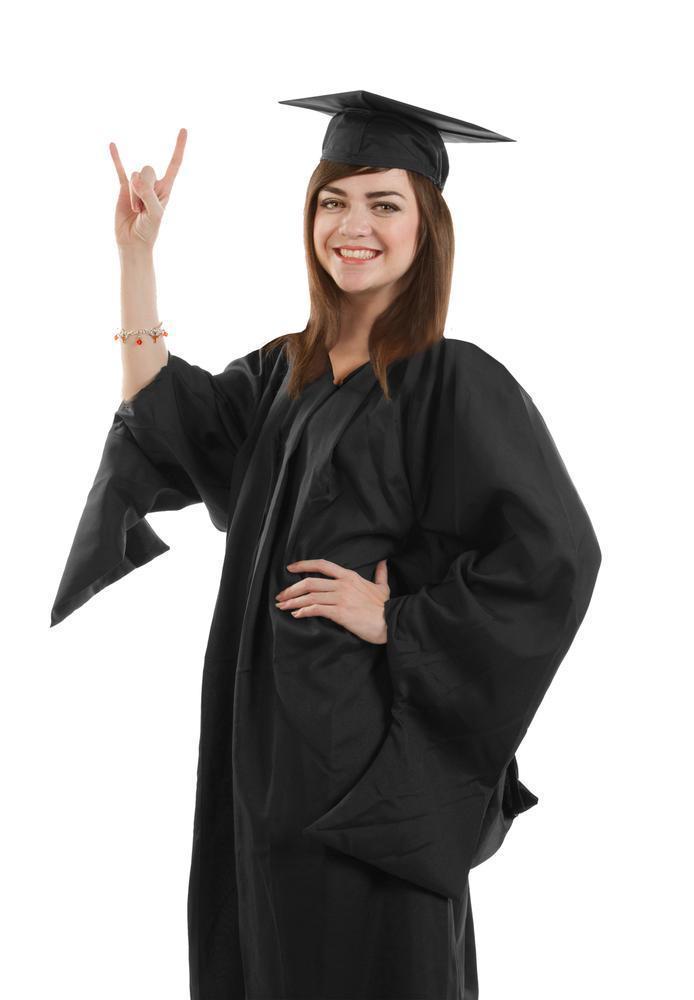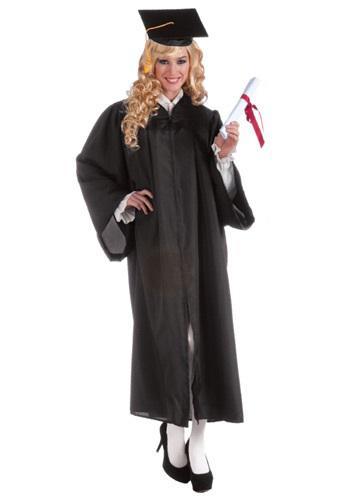The first image is the image on the left, the second image is the image on the right. For the images displayed, is the sentence "At least one gown in the pair has a yellow part to the sash." factually correct? Answer yes or no. No. 